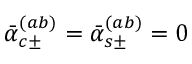<formula> <loc_0><loc_0><loc_500><loc_500>\bar { \alpha } _ { c \pm } ^ { ( a b ) } = \bar { \alpha } _ { s \pm } ^ { ( a b ) } = 0</formula> 